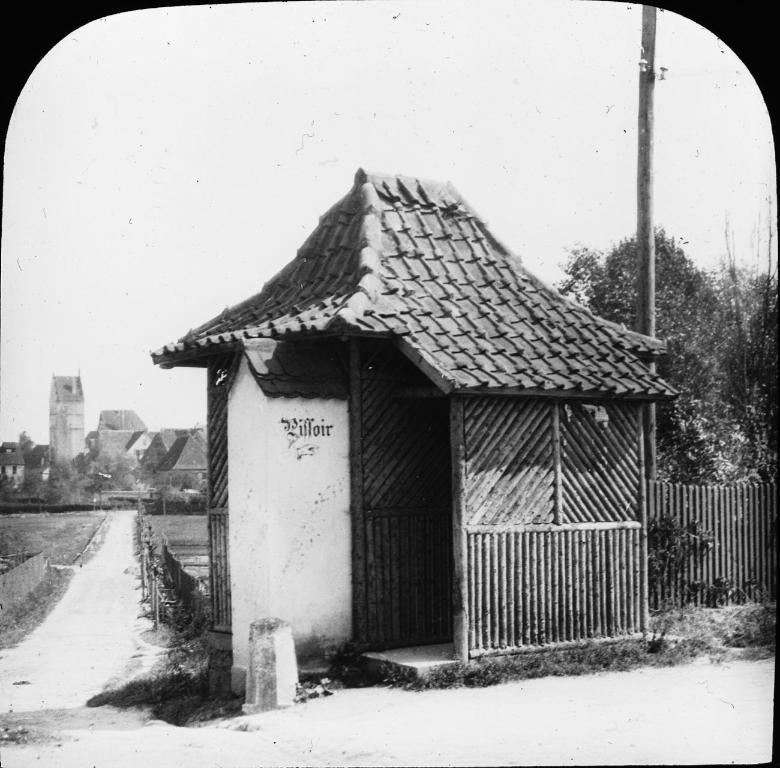What type of structures can be seen in the image? There are houses in the image. What type of vegetation is on the right side of the image? There are trees on the right side of the image. What color scheme is used in the image? The image is in black and white color. What type of pollution can be seen in the image? There is no pollution visible in the image; it is a black and white image of houses and trees. What type of veil is covering the houses in the image? There is no veil covering the houses in the image; they are visible in the black and white color scheme. 